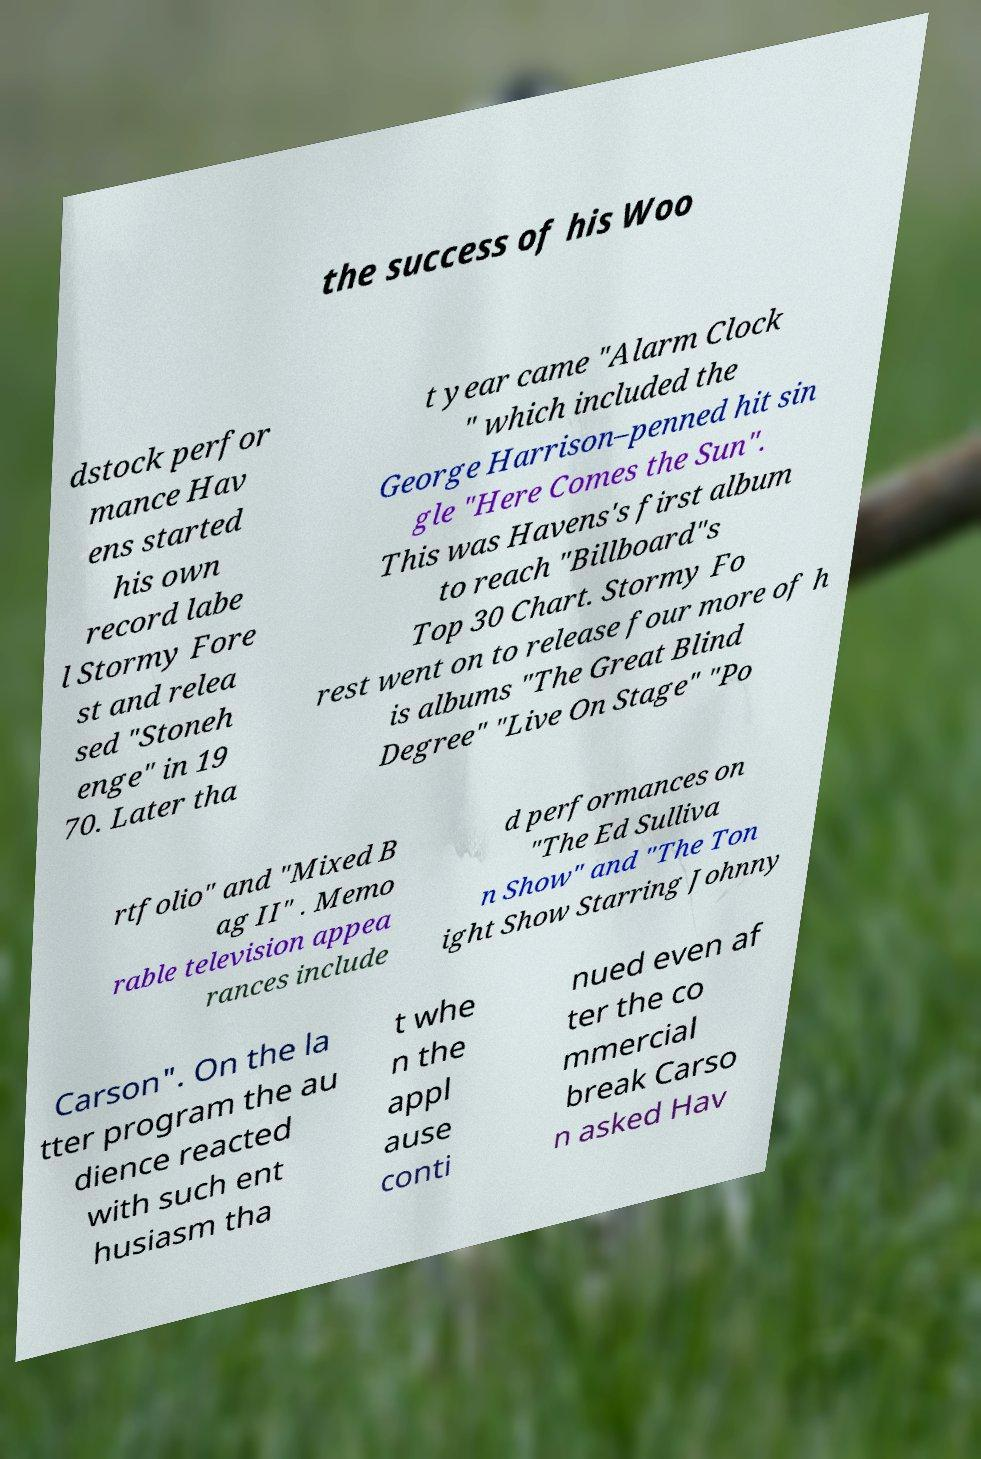Can you accurately transcribe the text from the provided image for me? the success of his Woo dstock perfor mance Hav ens started his own record labe l Stormy Fore st and relea sed "Stoneh enge" in 19 70. Later tha t year came "Alarm Clock " which included the George Harrison–penned hit sin gle "Here Comes the Sun". This was Havens's first album to reach "Billboard"s Top 30 Chart. Stormy Fo rest went on to release four more of h is albums "The Great Blind Degree" "Live On Stage" "Po rtfolio" and "Mixed B ag II" . Memo rable television appea rances include d performances on "The Ed Sulliva n Show" and "The Ton ight Show Starring Johnny Carson". On the la tter program the au dience reacted with such ent husiasm tha t whe n the appl ause conti nued even af ter the co mmercial break Carso n asked Hav 